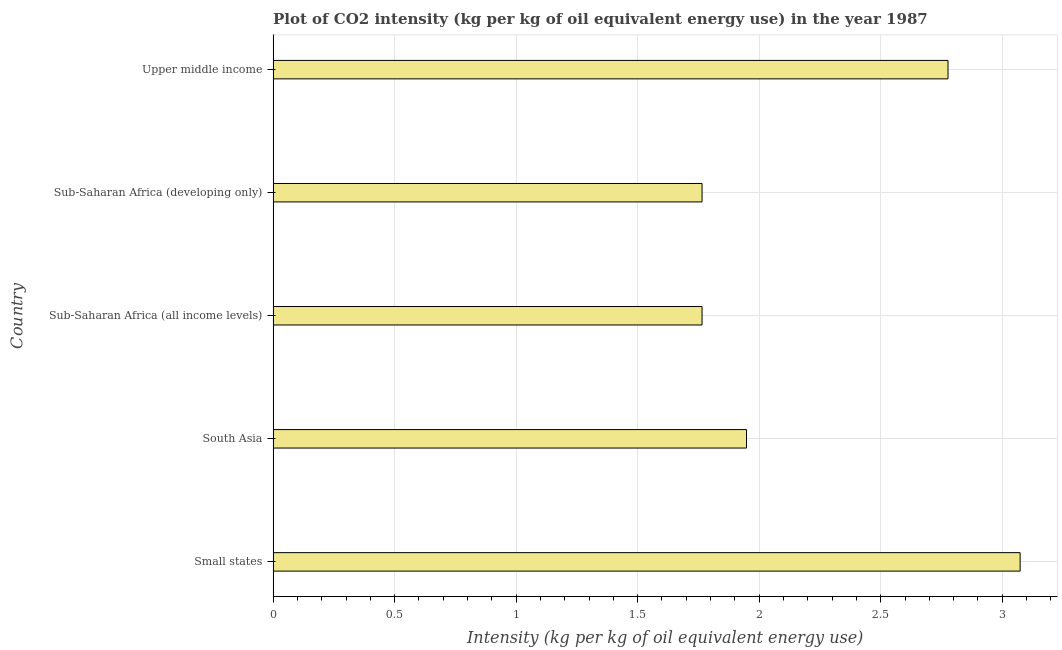Does the graph contain any zero values?
Provide a short and direct response. No. Does the graph contain grids?
Provide a short and direct response. Yes. What is the title of the graph?
Keep it short and to the point. Plot of CO2 intensity (kg per kg of oil equivalent energy use) in the year 1987. What is the label or title of the X-axis?
Ensure brevity in your answer.  Intensity (kg per kg of oil equivalent energy use). What is the co2 intensity in Upper middle income?
Provide a succinct answer. 2.78. Across all countries, what is the maximum co2 intensity?
Make the answer very short. 3.07. Across all countries, what is the minimum co2 intensity?
Provide a short and direct response. 1.76. In which country was the co2 intensity maximum?
Ensure brevity in your answer.  Small states. In which country was the co2 intensity minimum?
Give a very brief answer. Sub-Saharan Africa (all income levels). What is the sum of the co2 intensity?
Your response must be concise. 11.33. What is the difference between the co2 intensity in Small states and South Asia?
Offer a very short reply. 1.13. What is the average co2 intensity per country?
Provide a succinct answer. 2.27. What is the median co2 intensity?
Your answer should be compact. 1.95. In how many countries, is the co2 intensity greater than 2.1 kg?
Provide a succinct answer. 2. What is the ratio of the co2 intensity in South Asia to that in Upper middle income?
Provide a succinct answer. 0.7. What is the difference between the highest and the second highest co2 intensity?
Your answer should be compact. 0.3. What is the difference between the highest and the lowest co2 intensity?
Give a very brief answer. 1.31. In how many countries, is the co2 intensity greater than the average co2 intensity taken over all countries?
Your answer should be compact. 2. How many bars are there?
Offer a very short reply. 5. What is the difference between two consecutive major ticks on the X-axis?
Provide a succinct answer. 0.5. Are the values on the major ticks of X-axis written in scientific E-notation?
Your answer should be compact. No. What is the Intensity (kg per kg of oil equivalent energy use) of Small states?
Provide a succinct answer. 3.07. What is the Intensity (kg per kg of oil equivalent energy use) of South Asia?
Make the answer very short. 1.95. What is the Intensity (kg per kg of oil equivalent energy use) in Sub-Saharan Africa (all income levels)?
Ensure brevity in your answer.  1.76. What is the Intensity (kg per kg of oil equivalent energy use) of Sub-Saharan Africa (developing only)?
Ensure brevity in your answer.  1.76. What is the Intensity (kg per kg of oil equivalent energy use) of Upper middle income?
Provide a succinct answer. 2.78. What is the difference between the Intensity (kg per kg of oil equivalent energy use) in Small states and South Asia?
Your answer should be compact. 1.13. What is the difference between the Intensity (kg per kg of oil equivalent energy use) in Small states and Sub-Saharan Africa (all income levels)?
Keep it short and to the point. 1.31. What is the difference between the Intensity (kg per kg of oil equivalent energy use) in Small states and Sub-Saharan Africa (developing only)?
Offer a very short reply. 1.31. What is the difference between the Intensity (kg per kg of oil equivalent energy use) in Small states and Upper middle income?
Your answer should be compact. 0.3. What is the difference between the Intensity (kg per kg of oil equivalent energy use) in South Asia and Sub-Saharan Africa (all income levels)?
Provide a succinct answer. 0.18. What is the difference between the Intensity (kg per kg of oil equivalent energy use) in South Asia and Sub-Saharan Africa (developing only)?
Provide a succinct answer. 0.18. What is the difference between the Intensity (kg per kg of oil equivalent energy use) in South Asia and Upper middle income?
Give a very brief answer. -0.83. What is the difference between the Intensity (kg per kg of oil equivalent energy use) in Sub-Saharan Africa (all income levels) and Upper middle income?
Make the answer very short. -1.01. What is the difference between the Intensity (kg per kg of oil equivalent energy use) in Sub-Saharan Africa (developing only) and Upper middle income?
Your response must be concise. -1.01. What is the ratio of the Intensity (kg per kg of oil equivalent energy use) in Small states to that in South Asia?
Your answer should be compact. 1.58. What is the ratio of the Intensity (kg per kg of oil equivalent energy use) in Small states to that in Sub-Saharan Africa (all income levels)?
Give a very brief answer. 1.74. What is the ratio of the Intensity (kg per kg of oil equivalent energy use) in Small states to that in Sub-Saharan Africa (developing only)?
Your answer should be compact. 1.74. What is the ratio of the Intensity (kg per kg of oil equivalent energy use) in Small states to that in Upper middle income?
Make the answer very short. 1.11. What is the ratio of the Intensity (kg per kg of oil equivalent energy use) in South Asia to that in Sub-Saharan Africa (all income levels)?
Provide a succinct answer. 1.1. What is the ratio of the Intensity (kg per kg of oil equivalent energy use) in South Asia to that in Sub-Saharan Africa (developing only)?
Offer a very short reply. 1.1. What is the ratio of the Intensity (kg per kg of oil equivalent energy use) in South Asia to that in Upper middle income?
Keep it short and to the point. 0.7. What is the ratio of the Intensity (kg per kg of oil equivalent energy use) in Sub-Saharan Africa (all income levels) to that in Sub-Saharan Africa (developing only)?
Provide a succinct answer. 1. What is the ratio of the Intensity (kg per kg of oil equivalent energy use) in Sub-Saharan Africa (all income levels) to that in Upper middle income?
Give a very brief answer. 0.64. What is the ratio of the Intensity (kg per kg of oil equivalent energy use) in Sub-Saharan Africa (developing only) to that in Upper middle income?
Make the answer very short. 0.64. 